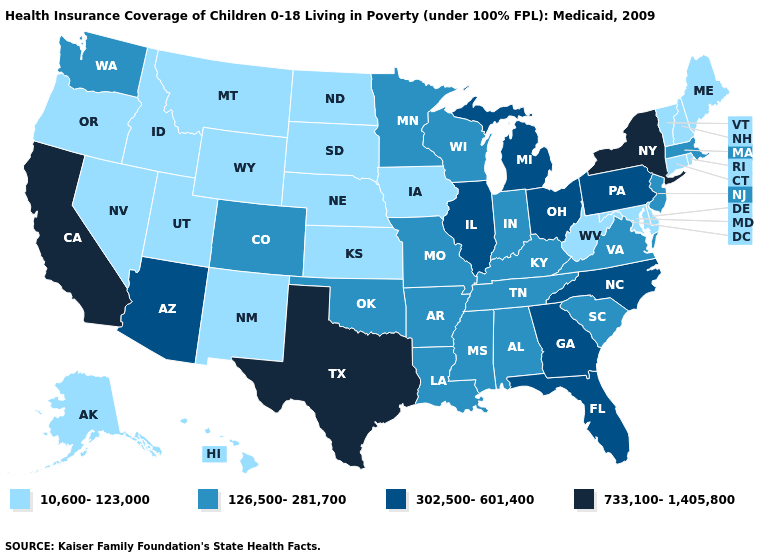What is the value of New York?
Keep it brief. 733,100-1,405,800. Which states have the lowest value in the MidWest?
Quick response, please. Iowa, Kansas, Nebraska, North Dakota, South Dakota. What is the value of Alaska?
Keep it brief. 10,600-123,000. Name the states that have a value in the range 733,100-1,405,800?
Keep it brief. California, New York, Texas. What is the value of Ohio?
Write a very short answer. 302,500-601,400. What is the highest value in the West ?
Short answer required. 733,100-1,405,800. Name the states that have a value in the range 302,500-601,400?
Quick response, please. Arizona, Florida, Georgia, Illinois, Michigan, North Carolina, Ohio, Pennsylvania. Among the states that border Minnesota , which have the lowest value?
Short answer required. Iowa, North Dakota, South Dakota. What is the value of Pennsylvania?
Write a very short answer. 302,500-601,400. Does Alabama have the lowest value in the USA?
Be succinct. No. Among the states that border Colorado , does Arizona have the highest value?
Answer briefly. Yes. What is the value of Montana?
Answer briefly. 10,600-123,000. Does the first symbol in the legend represent the smallest category?
Answer briefly. Yes. Name the states that have a value in the range 733,100-1,405,800?
Give a very brief answer. California, New York, Texas. What is the highest value in states that border Virginia?
Give a very brief answer. 302,500-601,400. 